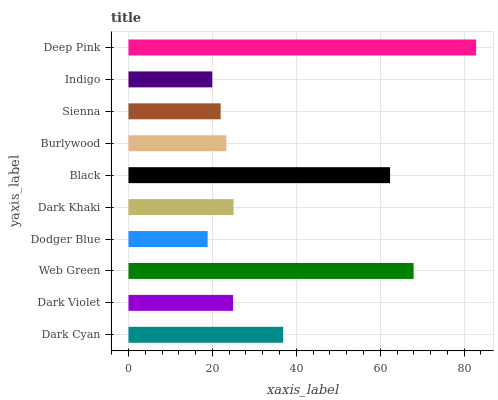Is Dodger Blue the minimum?
Answer yes or no. Yes. Is Deep Pink the maximum?
Answer yes or no. Yes. Is Dark Violet the minimum?
Answer yes or no. No. Is Dark Violet the maximum?
Answer yes or no. No. Is Dark Cyan greater than Dark Violet?
Answer yes or no. Yes. Is Dark Violet less than Dark Cyan?
Answer yes or no. Yes. Is Dark Violet greater than Dark Cyan?
Answer yes or no. No. Is Dark Cyan less than Dark Violet?
Answer yes or no. No. Is Dark Khaki the high median?
Answer yes or no. Yes. Is Dark Violet the low median?
Answer yes or no. Yes. Is Dodger Blue the high median?
Answer yes or no. No. Is Dark Cyan the low median?
Answer yes or no. No. 